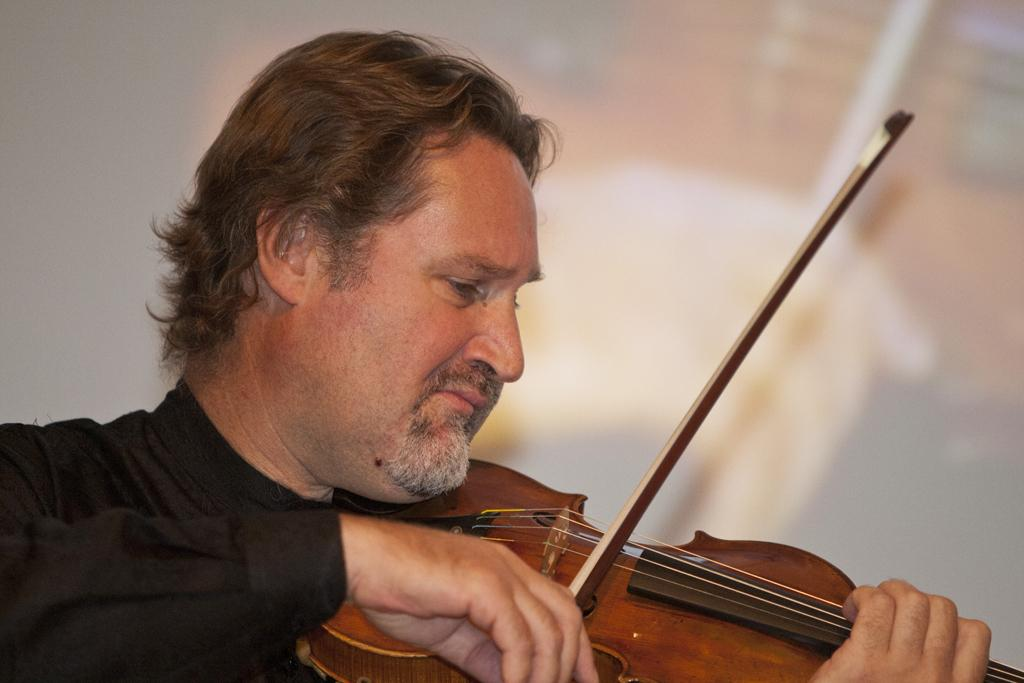What is the main subject of the image? There is a person in the image. What is the person wearing? The person is wearing a black color shirt. What is the person holding? The person is holding a violin. What is the person doing with the violin? The person is playing the violin. What can be seen in the background of the image? There is a screen in the background of the image, and the background is white in color. Can you see a nest in the image? No, there is no nest present in the image. What example of a musical instrument can be seen in the image? The image already shows an example of a musical instrument, which is the violin. 